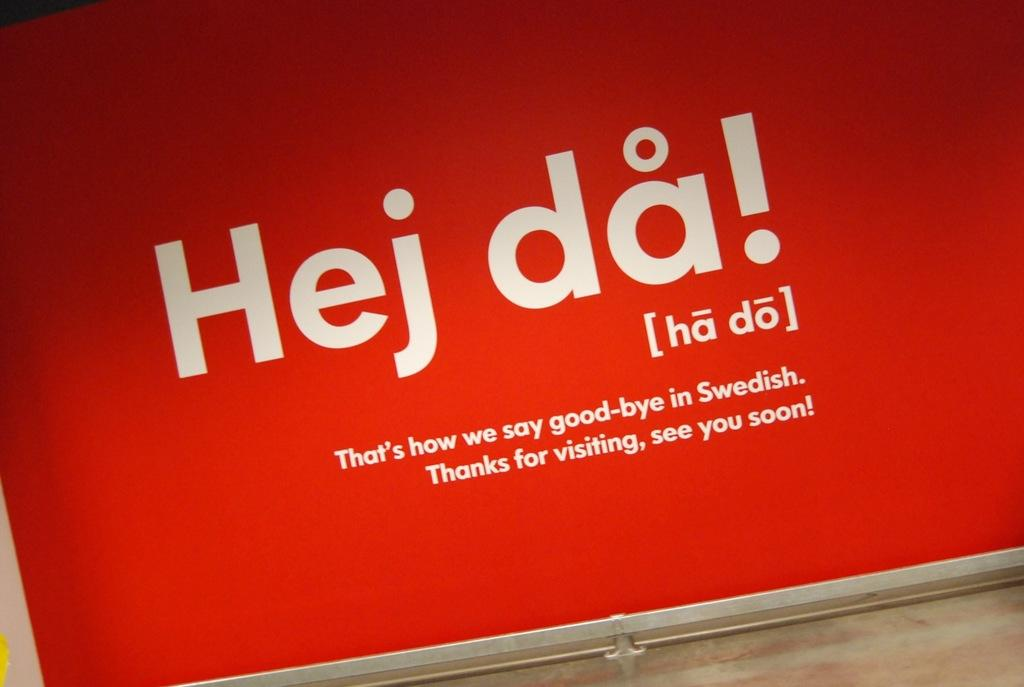<image>
Share a concise interpretation of the image provided. A red sign says Hej da, which is how you say goodbye in Swedish. 